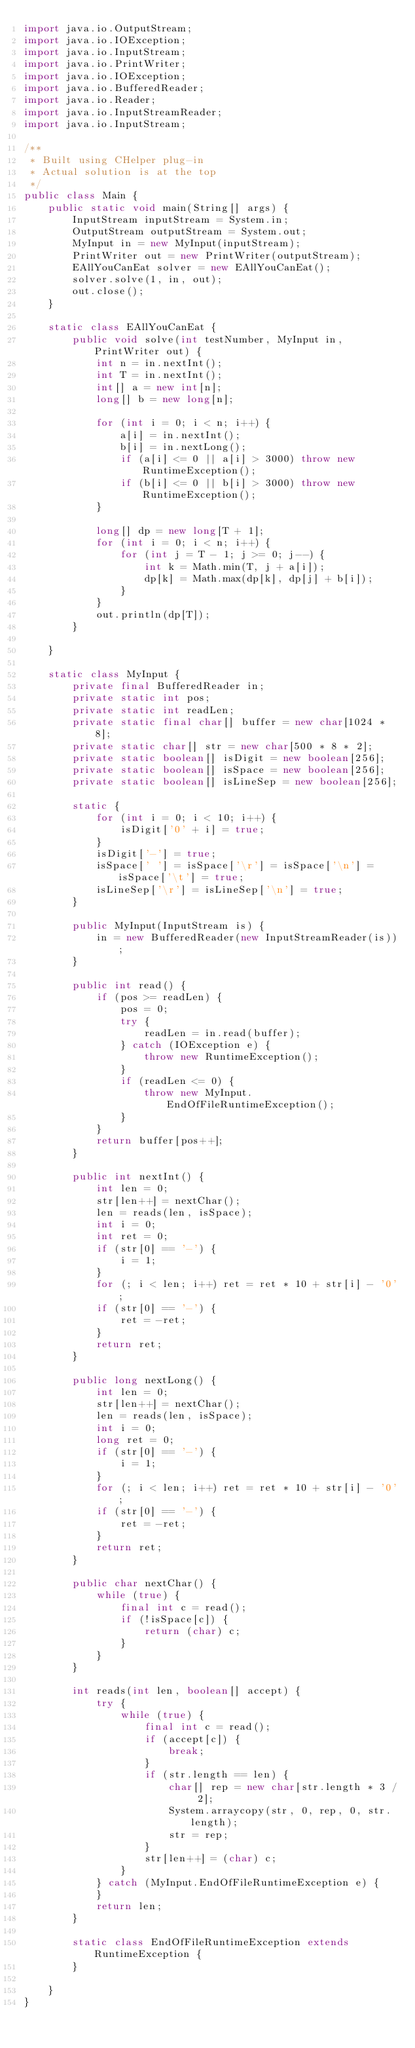Convert code to text. <code><loc_0><loc_0><loc_500><loc_500><_Java_>import java.io.OutputStream;
import java.io.IOException;
import java.io.InputStream;
import java.io.PrintWriter;
import java.io.IOException;
import java.io.BufferedReader;
import java.io.Reader;
import java.io.InputStreamReader;
import java.io.InputStream;

/**
 * Built using CHelper plug-in
 * Actual solution is at the top
 */
public class Main {
    public static void main(String[] args) {
        InputStream inputStream = System.in;
        OutputStream outputStream = System.out;
        MyInput in = new MyInput(inputStream);
        PrintWriter out = new PrintWriter(outputStream);
        EAllYouCanEat solver = new EAllYouCanEat();
        solver.solve(1, in, out);
        out.close();
    }

    static class EAllYouCanEat {
        public void solve(int testNumber, MyInput in, PrintWriter out) {
            int n = in.nextInt();
            int T = in.nextInt();
            int[] a = new int[n];
            long[] b = new long[n];

            for (int i = 0; i < n; i++) {
                a[i] = in.nextInt();
                b[i] = in.nextLong();
                if (a[i] <= 0 || a[i] > 3000) throw new RuntimeException();
                if (b[i] <= 0 || b[i] > 3000) throw new RuntimeException();
            }

            long[] dp = new long[T + 1];
            for (int i = 0; i < n; i++) {
                for (int j = T - 1; j >= 0; j--) {
                    int k = Math.min(T, j + a[i]);
                    dp[k] = Math.max(dp[k], dp[j] + b[i]);
                }
            }
            out.println(dp[T]);
        }

    }

    static class MyInput {
        private final BufferedReader in;
        private static int pos;
        private static int readLen;
        private static final char[] buffer = new char[1024 * 8];
        private static char[] str = new char[500 * 8 * 2];
        private static boolean[] isDigit = new boolean[256];
        private static boolean[] isSpace = new boolean[256];
        private static boolean[] isLineSep = new boolean[256];

        static {
            for (int i = 0; i < 10; i++) {
                isDigit['0' + i] = true;
            }
            isDigit['-'] = true;
            isSpace[' '] = isSpace['\r'] = isSpace['\n'] = isSpace['\t'] = true;
            isLineSep['\r'] = isLineSep['\n'] = true;
        }

        public MyInput(InputStream is) {
            in = new BufferedReader(new InputStreamReader(is));
        }

        public int read() {
            if (pos >= readLen) {
                pos = 0;
                try {
                    readLen = in.read(buffer);
                } catch (IOException e) {
                    throw new RuntimeException();
                }
                if (readLen <= 0) {
                    throw new MyInput.EndOfFileRuntimeException();
                }
            }
            return buffer[pos++];
        }

        public int nextInt() {
            int len = 0;
            str[len++] = nextChar();
            len = reads(len, isSpace);
            int i = 0;
            int ret = 0;
            if (str[0] == '-') {
                i = 1;
            }
            for (; i < len; i++) ret = ret * 10 + str[i] - '0';
            if (str[0] == '-') {
                ret = -ret;
            }
            return ret;
        }

        public long nextLong() {
            int len = 0;
            str[len++] = nextChar();
            len = reads(len, isSpace);
            int i = 0;
            long ret = 0;
            if (str[0] == '-') {
                i = 1;
            }
            for (; i < len; i++) ret = ret * 10 + str[i] - '0';
            if (str[0] == '-') {
                ret = -ret;
            }
            return ret;
        }

        public char nextChar() {
            while (true) {
                final int c = read();
                if (!isSpace[c]) {
                    return (char) c;
                }
            }
        }

        int reads(int len, boolean[] accept) {
            try {
                while (true) {
                    final int c = read();
                    if (accept[c]) {
                        break;
                    }
                    if (str.length == len) {
                        char[] rep = new char[str.length * 3 / 2];
                        System.arraycopy(str, 0, rep, 0, str.length);
                        str = rep;
                    }
                    str[len++] = (char) c;
                }
            } catch (MyInput.EndOfFileRuntimeException e) {
            }
            return len;
        }

        static class EndOfFileRuntimeException extends RuntimeException {
        }

    }
}

</code> 